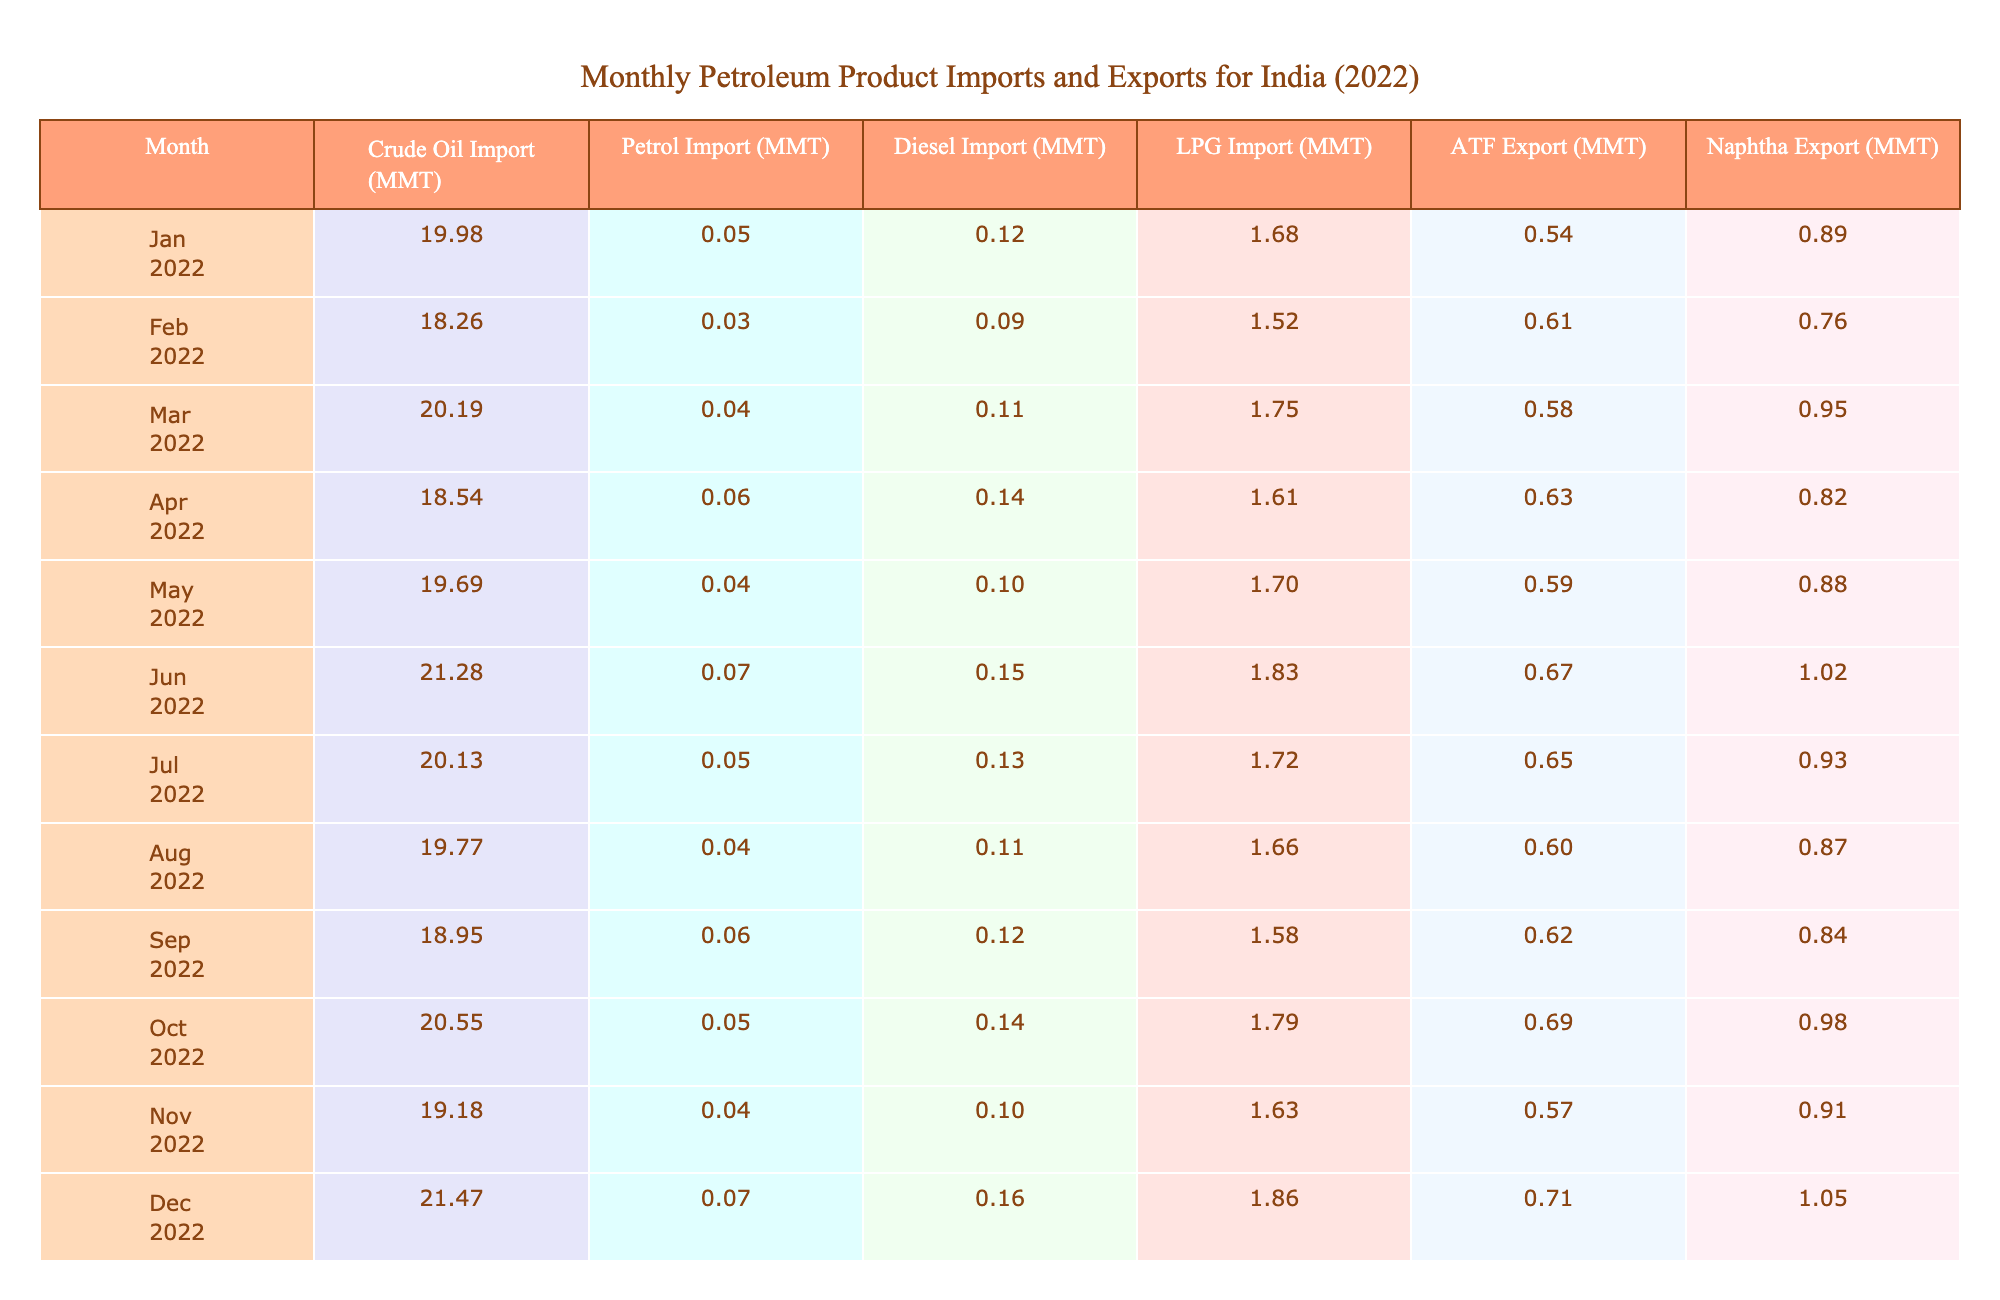What was the highest crude oil import in 2022? The table shows crude oil imports each month. The highest value is in December 2022 at 21.47 MMT.
Answer: 21.47 MMT What was the total LPG import for the year 2022? By adding all the monthly LPG imports: 1.68 + 1.52 + 1.75 + 1.61 + 1.70 + 1.83 + 1.72 + 1.66 + 1.58 + 1.79 + 1.63 + 1.86 = 20.12 MMT.
Answer: 20.12 MMT Which month had the highest petrol import? The table lists the petrol imports for each month. The highest value occurs in June 2022 at 0.07 MMT.
Answer: 0.07 MMT Was there an increase in diesel imports from January to February 2022? Comparing the figures for diesel imports, January has 0.12 MMT and February has 0.09 MMT. Since 0.09 is less than 0.12, it indicates a decrease.
Answer: No What was the average ATF export for the months from January to June? The ATF export values for January to June are: 0.54, 0.61, 0.58, 0.63, 0.59, 0.67. Their sum is 3.22 MMT, and dividing by 6 gives an average of 3.22/6 = 0.54 MMT.
Answer: 0.54 MMT In which month did India export more naphtha, October or November? By comparing the naphtha exports, October has 0.98 MMT and November has 0.91 MMT. Since 0.98 is greater than 0.91, October had more.
Answer: October What is the total difference between crude oil imports and total ATF exports for the year? The total crude oil imports are calculated as: 19.98 + 18.26 + ... + 21.47 = 236.22 MMT, and total ATF exports are 0.54 + 0.61 + ... + 0.71 = 7.28 MMT. Thus, the difference is 236.22 - 7.28 = 228.94 MMT.
Answer: 228.94 MMT Did the LPG imports show any increasing trend from January to December? By reviewing the values; they fluctuate but there's no consistent upward trend. For instance, January has 1.68 MMT and December has 1.86 MMT, but values in between are variable and include both increases and decreases.
Answer: No What month had the smallest total exports compared to other months? Examining the ATF and naphtha export values shows that November had the smallest naphtha export at 0.91 MMT. However, December had a total of ATF plus naphtha as 1.76 MMT. Thus, November is less than December.
Answer: November Was the total diesel import in June higher than the total LPG import for the same month? In June, diesel import is 0.15 MMT and LPG import is 1.83 MMT. Comparing these indicates that 0.15 MMT is less than 1.83 MMT.
Answer: Yes 